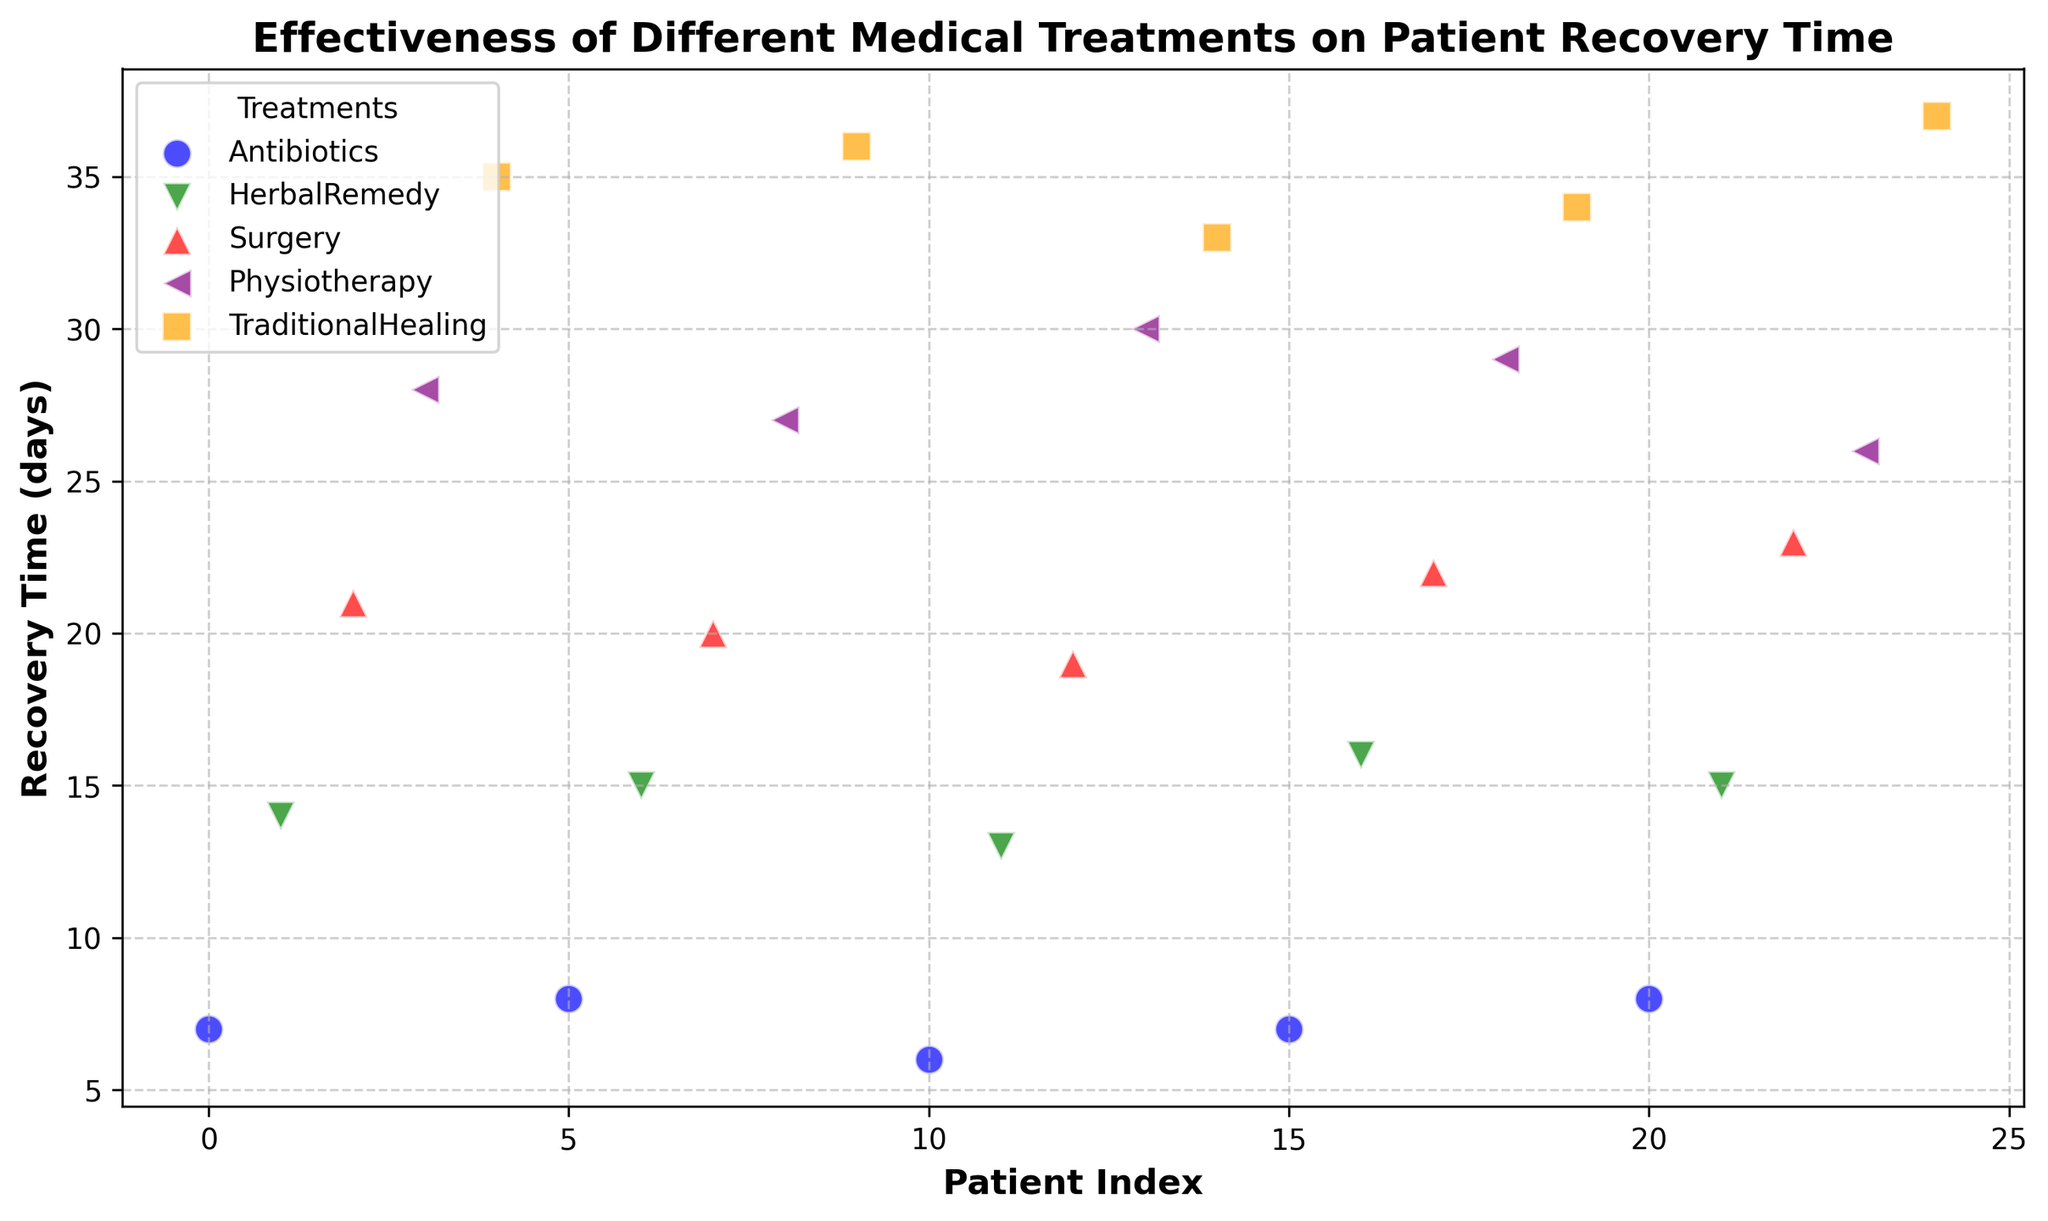Which treatment has the lowest average recovery time? To determine this, calculate the average recovery time for each treatment. For Antibiotics: (7+8+6+7+8)/5 = 7.2, HerbalRemedy: (14+15+13+16+15)/5 = 14.6, Surgery: (21+20+19+22+23)/5 = 21, Physiotherapy: (28+27+30+29+26)/5 = 28, TraditionalHealing: (35+36+33+34+37)/5 = 35.
Answer: Antibiotics Compare Antibiotics and TraditionalHealing: Which has a higher recovery time in its best outcome? Check the minimum recovery times for Antibiotics and TraditionalHealing. For Antibiotics, the minimum recovery time is 6 days. For TraditionalHealing, the minimum recovery time is 33 days.
Answer: TraditionalHealing Which treatment shows the most variance in recovery times? Compare the range (difference between max and min recovery times) for each treatment. Antibiotics ranges from 6 to 8 (range = 2), HerbalRemedy from 13 to 16 (range = 3), Surgery from 19 to 23 (range = 4), Physiotherapy from 26 to 30 (range = 4), TraditionalHealing from 33 to 37 (range = 4).
Answer: Surgery, Physiotherapy, TraditionalHealing Does any two treatments have overlapping recovery times across all patients? Check if there's a recovery time that both treatments share. None of the treatment options have overlapping recovery times in all patients. Antibiotics: 6-8, HerbalRemedy: 13-16, Surgery: 19-23, Physiotherapy: 26-30, TraditionalHealing: 33-37.
Answer: No Which treatment has consistent recovery times across patients, and what is the range? Calculate the range for each treatment. Antibiotics: 6-8 (range = 2), HerbalRemedy: 13-16 (range = 3), Surgery: 19-23 (range = 4), Physiotherapy: 26-30 (range = 4), TraditionalHealing: 33-37 (range = 4). The smallest range indicates consistency.
Answer: Antibiotics, range = 2 